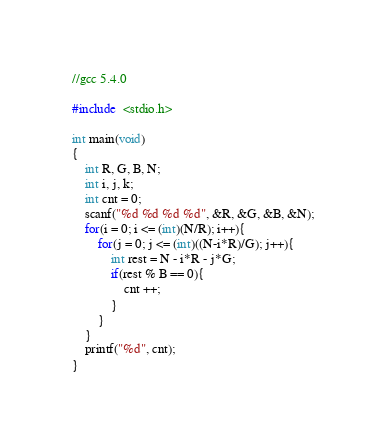<code> <loc_0><loc_0><loc_500><loc_500><_C_>//gcc 5.4.0

#include  <stdio.h>

int main(void)
{
    int R, G, B, N;
    int i, j, k;
    int cnt = 0;
    scanf("%d %d %d %d", &R, &G, &B, &N);
    for(i = 0; i <= (int)(N/R); i++){
        for(j = 0; j <= (int)((N-i*R)/G); j++){
            int rest = N - i*R - j*G;
            if(rest % B == 0){
                cnt ++;
            }
        }
    }
    printf("%d", cnt);
}</code> 